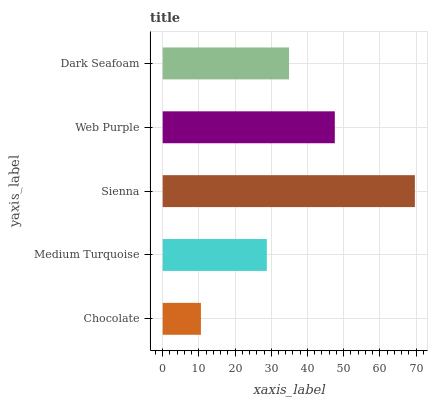Is Chocolate the minimum?
Answer yes or no. Yes. Is Sienna the maximum?
Answer yes or no. Yes. Is Medium Turquoise the minimum?
Answer yes or no. No. Is Medium Turquoise the maximum?
Answer yes or no. No. Is Medium Turquoise greater than Chocolate?
Answer yes or no. Yes. Is Chocolate less than Medium Turquoise?
Answer yes or no. Yes. Is Chocolate greater than Medium Turquoise?
Answer yes or no. No. Is Medium Turquoise less than Chocolate?
Answer yes or no. No. Is Dark Seafoam the high median?
Answer yes or no. Yes. Is Dark Seafoam the low median?
Answer yes or no. Yes. Is Chocolate the high median?
Answer yes or no. No. Is Chocolate the low median?
Answer yes or no. No. 